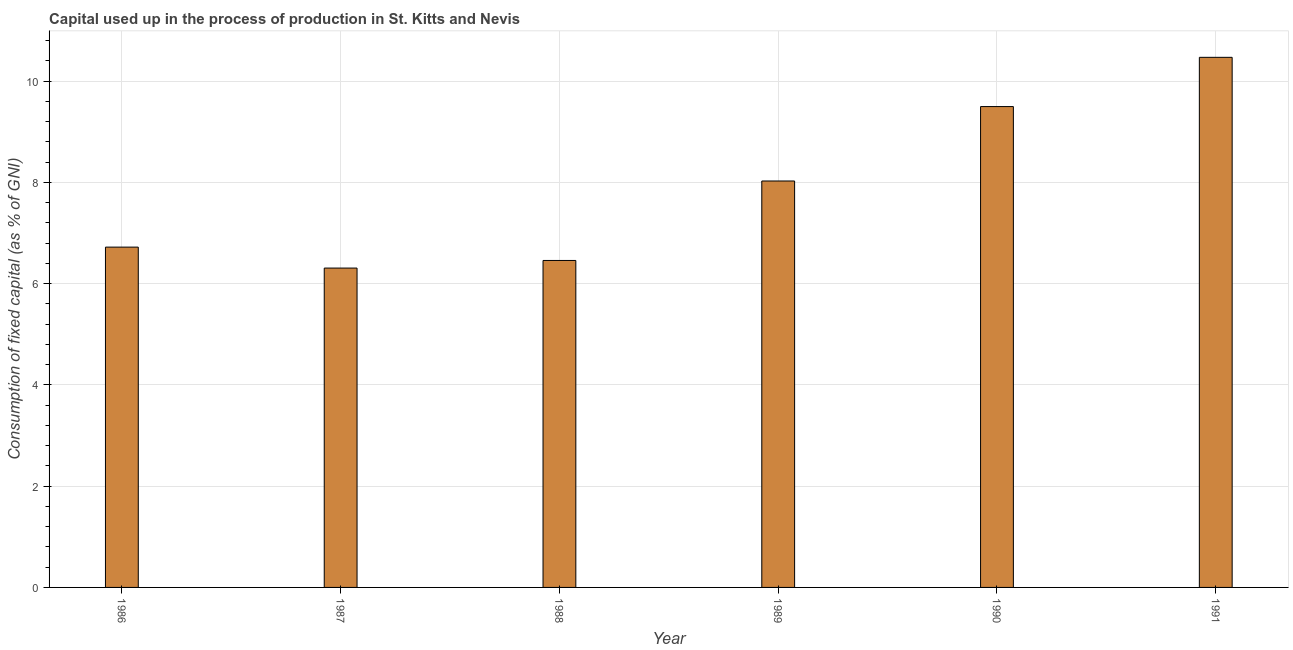Does the graph contain any zero values?
Make the answer very short. No. What is the title of the graph?
Ensure brevity in your answer.  Capital used up in the process of production in St. Kitts and Nevis. What is the label or title of the X-axis?
Ensure brevity in your answer.  Year. What is the label or title of the Y-axis?
Your response must be concise. Consumption of fixed capital (as % of GNI). What is the consumption of fixed capital in 1986?
Give a very brief answer. 6.72. Across all years, what is the maximum consumption of fixed capital?
Your answer should be compact. 10.47. Across all years, what is the minimum consumption of fixed capital?
Make the answer very short. 6.31. In which year was the consumption of fixed capital minimum?
Offer a terse response. 1987. What is the sum of the consumption of fixed capital?
Ensure brevity in your answer.  47.48. What is the difference between the consumption of fixed capital in 1989 and 1991?
Your answer should be very brief. -2.44. What is the average consumption of fixed capital per year?
Provide a succinct answer. 7.91. What is the median consumption of fixed capital?
Keep it short and to the point. 7.37. In how many years, is the consumption of fixed capital greater than 0.8 %?
Keep it short and to the point. 6. Do a majority of the years between 1991 and 1989 (inclusive) have consumption of fixed capital greater than 2.8 %?
Provide a short and direct response. Yes. What is the ratio of the consumption of fixed capital in 1986 to that in 1991?
Offer a very short reply. 0.64. Is the consumption of fixed capital in 1987 less than that in 1990?
Provide a succinct answer. Yes. Is the difference between the consumption of fixed capital in 1986 and 1989 greater than the difference between any two years?
Ensure brevity in your answer.  No. What is the difference between the highest and the second highest consumption of fixed capital?
Ensure brevity in your answer.  0.97. Is the sum of the consumption of fixed capital in 1989 and 1990 greater than the maximum consumption of fixed capital across all years?
Provide a succinct answer. Yes. What is the difference between the highest and the lowest consumption of fixed capital?
Give a very brief answer. 4.16. In how many years, is the consumption of fixed capital greater than the average consumption of fixed capital taken over all years?
Keep it short and to the point. 3. Are all the bars in the graph horizontal?
Make the answer very short. No. What is the difference between two consecutive major ticks on the Y-axis?
Your response must be concise. 2. What is the Consumption of fixed capital (as % of GNI) of 1986?
Give a very brief answer. 6.72. What is the Consumption of fixed capital (as % of GNI) of 1987?
Make the answer very short. 6.31. What is the Consumption of fixed capital (as % of GNI) in 1988?
Your response must be concise. 6.46. What is the Consumption of fixed capital (as % of GNI) of 1989?
Give a very brief answer. 8.03. What is the Consumption of fixed capital (as % of GNI) in 1990?
Make the answer very short. 9.5. What is the Consumption of fixed capital (as % of GNI) of 1991?
Give a very brief answer. 10.47. What is the difference between the Consumption of fixed capital (as % of GNI) in 1986 and 1987?
Your response must be concise. 0.41. What is the difference between the Consumption of fixed capital (as % of GNI) in 1986 and 1988?
Provide a succinct answer. 0.26. What is the difference between the Consumption of fixed capital (as % of GNI) in 1986 and 1989?
Your answer should be compact. -1.31. What is the difference between the Consumption of fixed capital (as % of GNI) in 1986 and 1990?
Offer a very short reply. -2.78. What is the difference between the Consumption of fixed capital (as % of GNI) in 1986 and 1991?
Provide a short and direct response. -3.75. What is the difference between the Consumption of fixed capital (as % of GNI) in 1987 and 1988?
Make the answer very short. -0.15. What is the difference between the Consumption of fixed capital (as % of GNI) in 1987 and 1989?
Your response must be concise. -1.72. What is the difference between the Consumption of fixed capital (as % of GNI) in 1987 and 1990?
Provide a short and direct response. -3.19. What is the difference between the Consumption of fixed capital (as % of GNI) in 1987 and 1991?
Provide a succinct answer. -4.16. What is the difference between the Consumption of fixed capital (as % of GNI) in 1988 and 1989?
Your answer should be compact. -1.57. What is the difference between the Consumption of fixed capital (as % of GNI) in 1988 and 1990?
Your answer should be compact. -3.04. What is the difference between the Consumption of fixed capital (as % of GNI) in 1988 and 1991?
Keep it short and to the point. -4.01. What is the difference between the Consumption of fixed capital (as % of GNI) in 1989 and 1990?
Provide a short and direct response. -1.47. What is the difference between the Consumption of fixed capital (as % of GNI) in 1989 and 1991?
Your response must be concise. -2.44. What is the difference between the Consumption of fixed capital (as % of GNI) in 1990 and 1991?
Offer a terse response. -0.97. What is the ratio of the Consumption of fixed capital (as % of GNI) in 1986 to that in 1987?
Your answer should be compact. 1.07. What is the ratio of the Consumption of fixed capital (as % of GNI) in 1986 to that in 1988?
Your answer should be compact. 1.04. What is the ratio of the Consumption of fixed capital (as % of GNI) in 1986 to that in 1989?
Give a very brief answer. 0.84. What is the ratio of the Consumption of fixed capital (as % of GNI) in 1986 to that in 1990?
Offer a terse response. 0.71. What is the ratio of the Consumption of fixed capital (as % of GNI) in 1986 to that in 1991?
Provide a succinct answer. 0.64. What is the ratio of the Consumption of fixed capital (as % of GNI) in 1987 to that in 1988?
Provide a succinct answer. 0.98. What is the ratio of the Consumption of fixed capital (as % of GNI) in 1987 to that in 1989?
Keep it short and to the point. 0.79. What is the ratio of the Consumption of fixed capital (as % of GNI) in 1987 to that in 1990?
Provide a succinct answer. 0.66. What is the ratio of the Consumption of fixed capital (as % of GNI) in 1987 to that in 1991?
Make the answer very short. 0.6. What is the ratio of the Consumption of fixed capital (as % of GNI) in 1988 to that in 1989?
Offer a terse response. 0.8. What is the ratio of the Consumption of fixed capital (as % of GNI) in 1988 to that in 1990?
Provide a succinct answer. 0.68. What is the ratio of the Consumption of fixed capital (as % of GNI) in 1988 to that in 1991?
Keep it short and to the point. 0.62. What is the ratio of the Consumption of fixed capital (as % of GNI) in 1989 to that in 1990?
Provide a short and direct response. 0.84. What is the ratio of the Consumption of fixed capital (as % of GNI) in 1989 to that in 1991?
Ensure brevity in your answer.  0.77. What is the ratio of the Consumption of fixed capital (as % of GNI) in 1990 to that in 1991?
Your answer should be very brief. 0.91. 